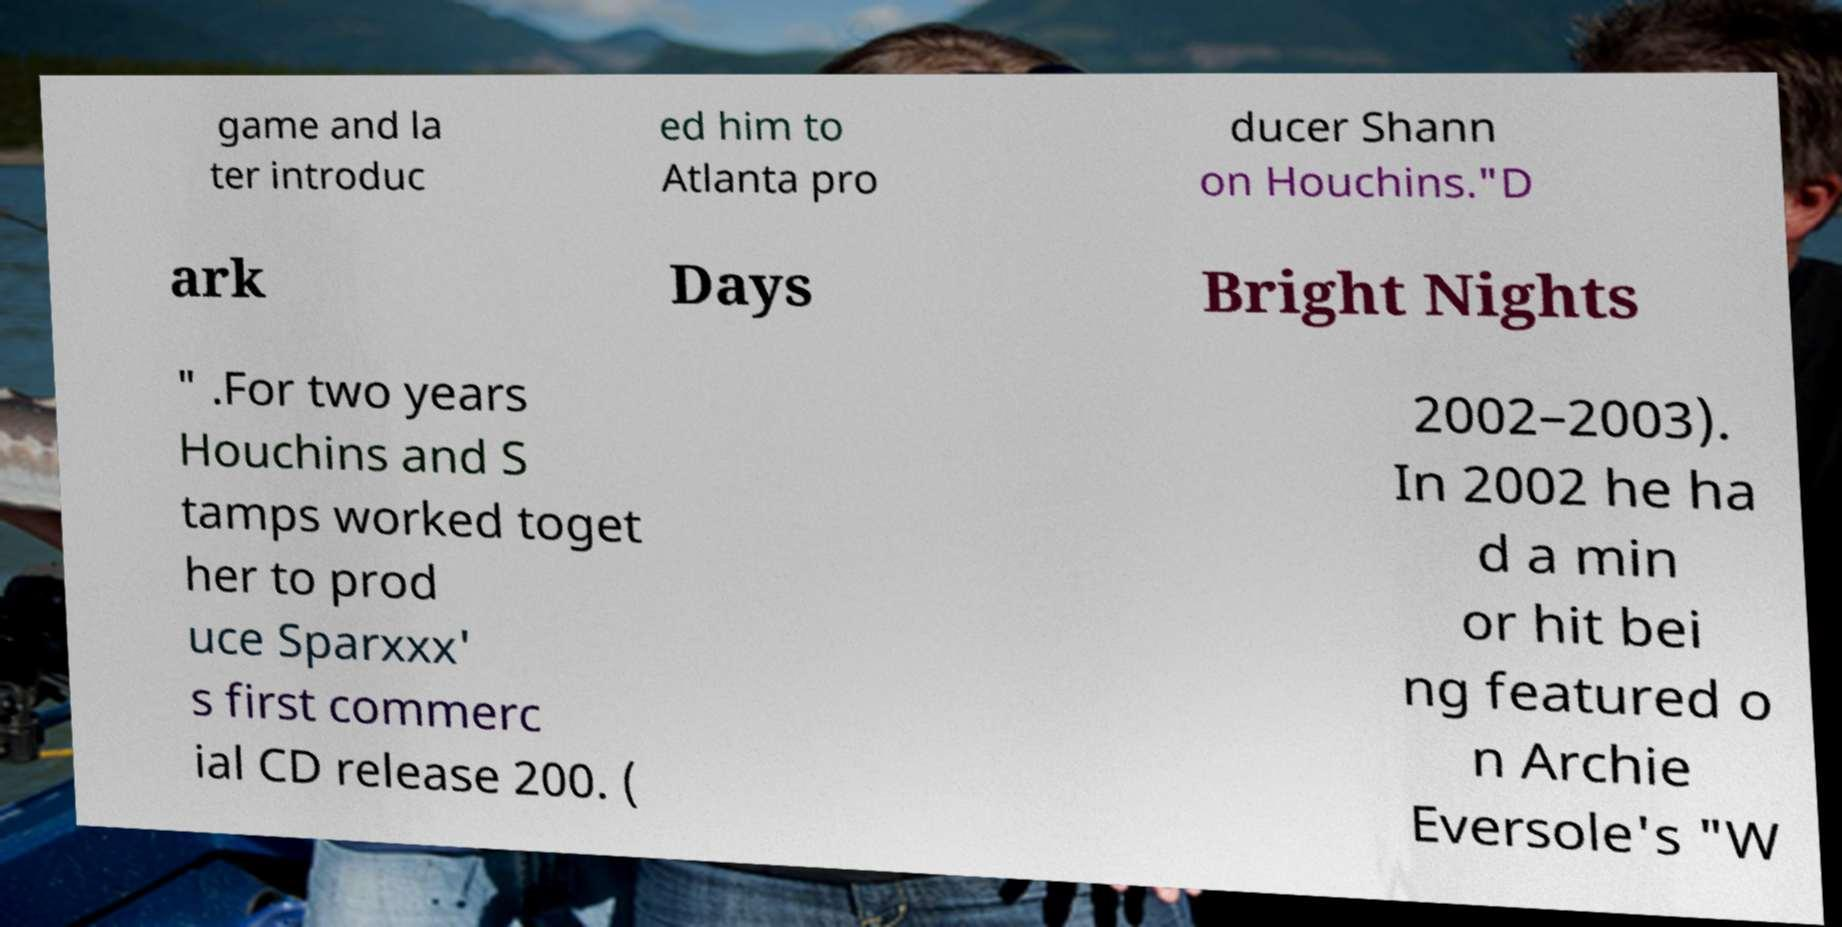I need the written content from this picture converted into text. Can you do that? game and la ter introduc ed him to Atlanta pro ducer Shann on Houchins."D ark Days Bright Nights " .For two years Houchins and S tamps worked toget her to prod uce Sparxxx' s first commerc ial CD release 200. ( 2002–2003). In 2002 he ha d a min or hit bei ng featured o n Archie Eversole's "W 